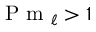<formula> <loc_0><loc_0><loc_500><loc_500>P m _ { \ell } > 1</formula> 